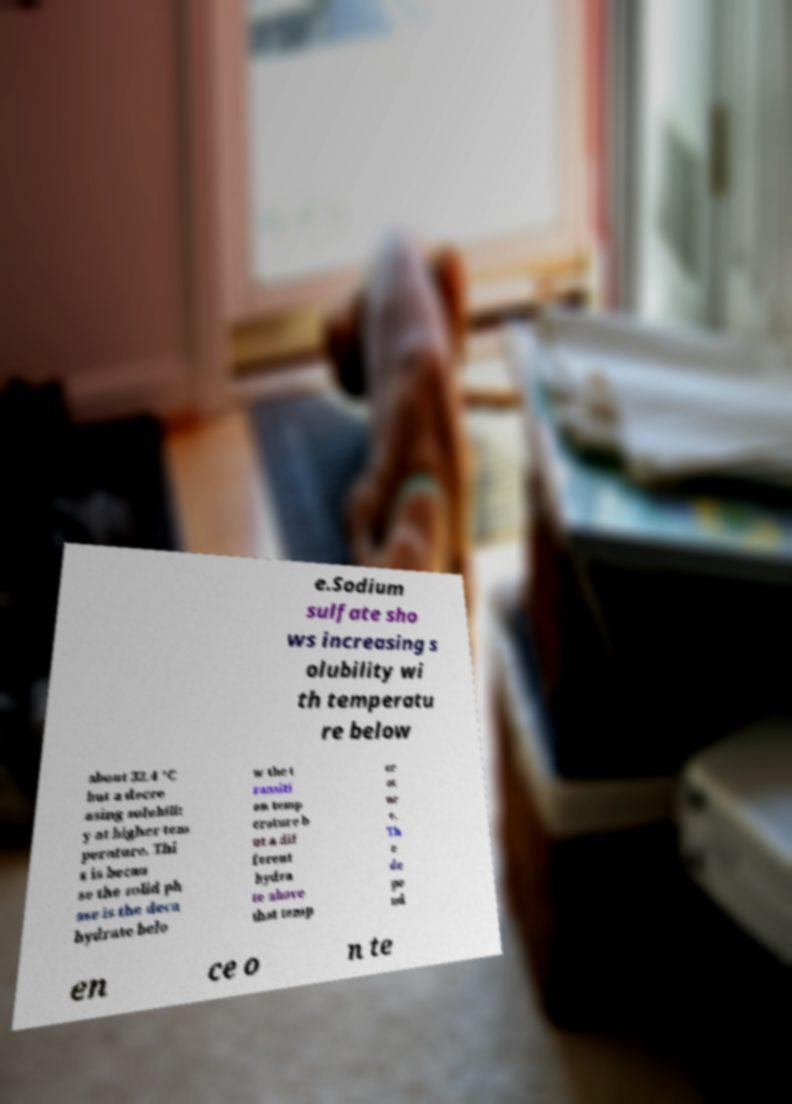Can you read and provide the text displayed in the image?This photo seems to have some interesting text. Can you extract and type it out for me? e.Sodium sulfate sho ws increasing s olubility wi th temperatu re below about 32.4 °C but a decre asing solubilit y at higher tem perature. Thi s is becau se the solid ph ase is the deca hydrate belo w the t ransiti on temp erature b ut a dif ferent hydra te above that temp er at ur e. Th e de pe nd en ce o n te 